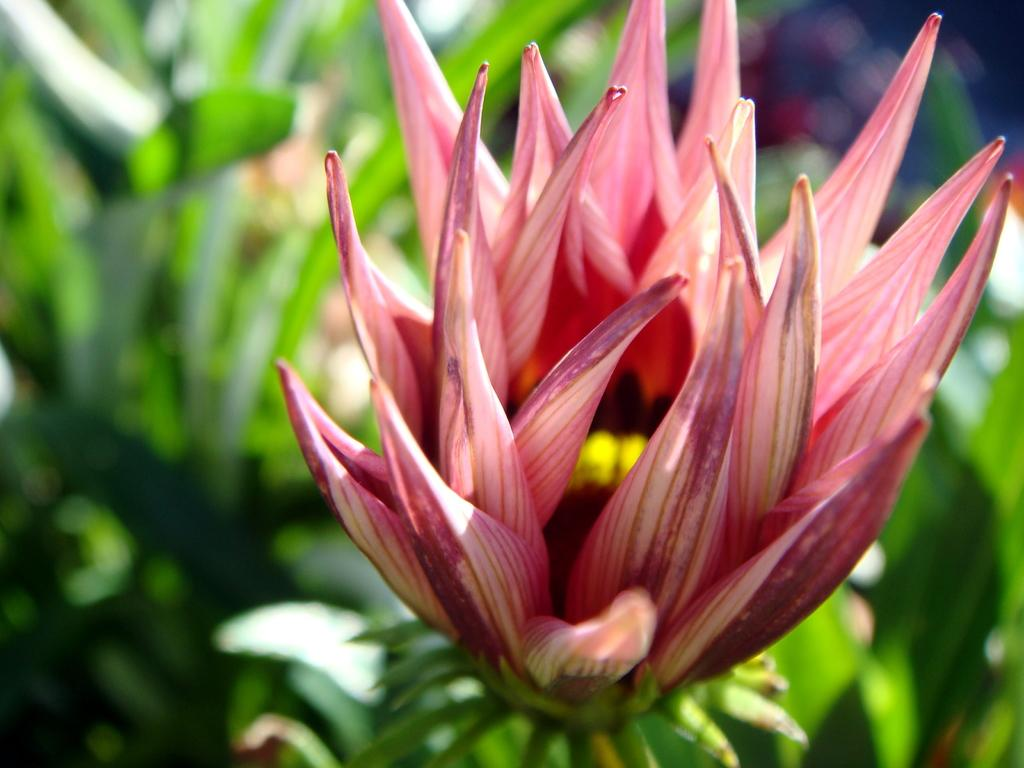What is located in the foreground of the image? There is a flower in the foreground of the image. What can be seen in the background of the image? There is greenery in the background of the image. What type of lettuce is being used as a reaction to the flower in the image? There is no lettuce or reaction present in the image; it features a flower in the foreground and greenery in the background. 